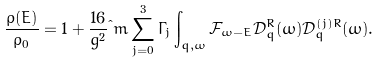<formula> <loc_0><loc_0><loc_500><loc_500>\frac { \rho ( E ) } { \rho _ { 0 } } = 1 & + \frac { 1 6 } { g ^ { 2 } } \i m \sum _ { j = 0 } ^ { 3 } \Gamma _ { j } \int _ { q , \omega } \mathcal { F } _ { \omega - E } \mathcal { D } ^ { R } _ { q } ( \omega ) \mathcal { D } ^ { ( j ) R } _ { q } ( \omega ) .</formula> 